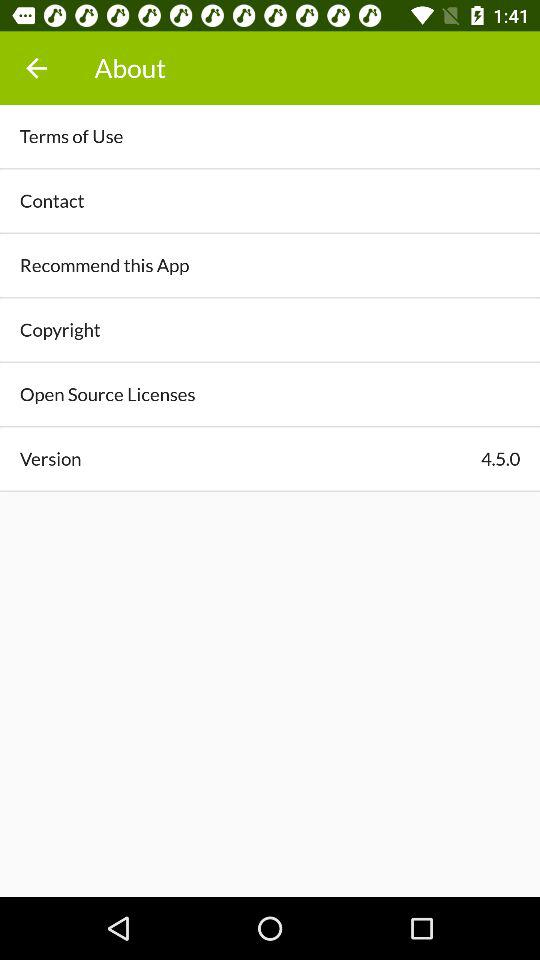How many items are there in the About section?
Answer the question using a single word or phrase. 6 